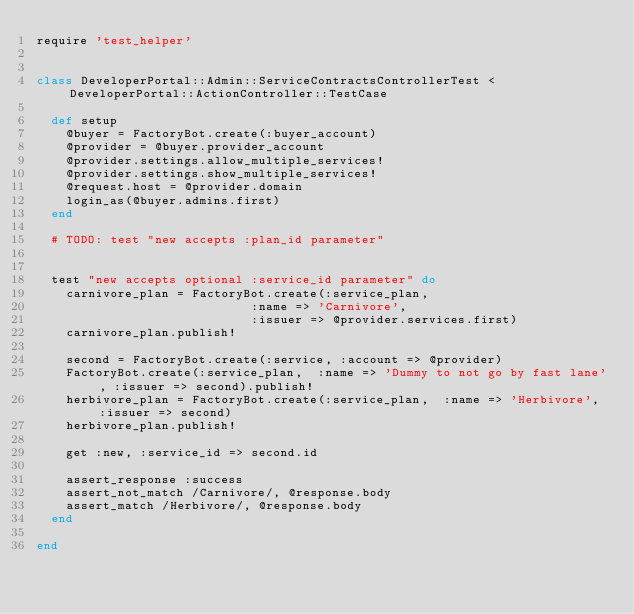Convert code to text. <code><loc_0><loc_0><loc_500><loc_500><_Ruby_>require 'test_helper'


class DeveloperPortal::Admin::ServiceContractsControllerTest <  DeveloperPortal::ActionController::TestCase

  def setup
    @buyer = FactoryBot.create(:buyer_account)
    @provider = @buyer.provider_account
    @provider.settings.allow_multiple_services!
    @provider.settings.show_multiple_services!
    @request.host = @provider.domain
    login_as(@buyer.admins.first)
  end

  # TODO: test "new accepts :plan_id parameter"


  test "new accepts optional :service_id parameter" do
    carnivore_plan = FactoryBot.create(:service_plan,
                             :name => 'Carnivore',
                             :issuer => @provider.services.first)
    carnivore_plan.publish!

    second = FactoryBot.create(:service, :account => @provider)
    FactoryBot.create(:service_plan,  :name => 'Dummy to not go by fast lane', :issuer => second).publish!
    herbivore_plan = FactoryBot.create(:service_plan,  :name => 'Herbivore', :issuer => second)
    herbivore_plan.publish!

    get :new, :service_id => second.id

    assert_response :success
    assert_not_match /Carnivore/, @response.body
    assert_match /Herbivore/, @response.body
  end

end
</code> 